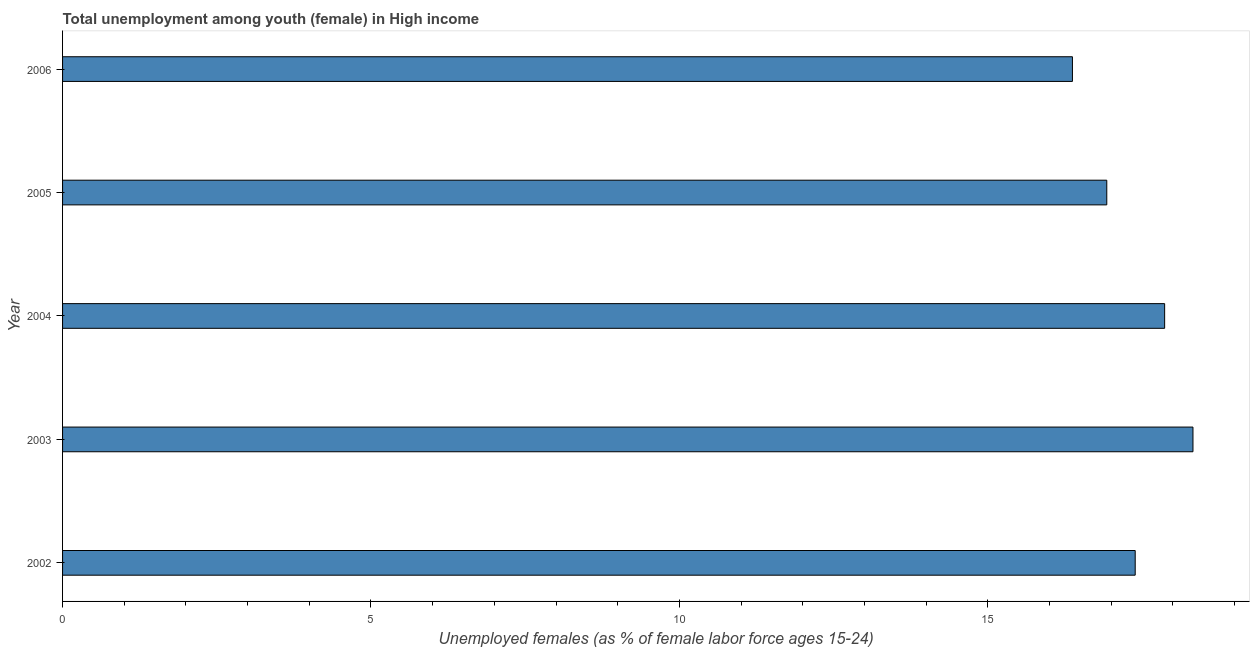Does the graph contain any zero values?
Provide a succinct answer. No. What is the title of the graph?
Provide a short and direct response. Total unemployment among youth (female) in High income. What is the label or title of the X-axis?
Your answer should be compact. Unemployed females (as % of female labor force ages 15-24). What is the label or title of the Y-axis?
Your response must be concise. Year. What is the unemployed female youth population in 2003?
Provide a short and direct response. 18.33. Across all years, what is the maximum unemployed female youth population?
Ensure brevity in your answer.  18.33. Across all years, what is the minimum unemployed female youth population?
Offer a terse response. 16.37. In which year was the unemployed female youth population maximum?
Provide a succinct answer. 2003. In which year was the unemployed female youth population minimum?
Provide a succinct answer. 2006. What is the sum of the unemployed female youth population?
Offer a terse response. 86.89. What is the difference between the unemployed female youth population in 2004 and 2005?
Keep it short and to the point. 0.94. What is the average unemployed female youth population per year?
Keep it short and to the point. 17.38. What is the median unemployed female youth population?
Your answer should be very brief. 17.39. Do a majority of the years between 2003 and 2004 (inclusive) have unemployed female youth population greater than 8 %?
Offer a very short reply. Yes. What is the ratio of the unemployed female youth population in 2002 to that in 2004?
Ensure brevity in your answer.  0.97. Is the difference between the unemployed female youth population in 2003 and 2004 greater than the difference between any two years?
Your answer should be very brief. No. What is the difference between the highest and the second highest unemployed female youth population?
Your answer should be very brief. 0.46. What is the difference between the highest and the lowest unemployed female youth population?
Your response must be concise. 1.95. In how many years, is the unemployed female youth population greater than the average unemployed female youth population taken over all years?
Offer a very short reply. 3. How many years are there in the graph?
Make the answer very short. 5. What is the difference between two consecutive major ticks on the X-axis?
Ensure brevity in your answer.  5. What is the Unemployed females (as % of female labor force ages 15-24) of 2002?
Your answer should be compact. 17.39. What is the Unemployed females (as % of female labor force ages 15-24) in 2003?
Your answer should be compact. 18.33. What is the Unemployed females (as % of female labor force ages 15-24) in 2004?
Your answer should be very brief. 17.87. What is the Unemployed females (as % of female labor force ages 15-24) of 2005?
Provide a short and direct response. 16.93. What is the Unemployed females (as % of female labor force ages 15-24) of 2006?
Make the answer very short. 16.37. What is the difference between the Unemployed females (as % of female labor force ages 15-24) in 2002 and 2003?
Keep it short and to the point. -0.94. What is the difference between the Unemployed females (as % of female labor force ages 15-24) in 2002 and 2004?
Your answer should be very brief. -0.48. What is the difference between the Unemployed females (as % of female labor force ages 15-24) in 2002 and 2005?
Offer a terse response. 0.46. What is the difference between the Unemployed females (as % of female labor force ages 15-24) in 2002 and 2006?
Your response must be concise. 1.02. What is the difference between the Unemployed females (as % of female labor force ages 15-24) in 2003 and 2004?
Offer a very short reply. 0.46. What is the difference between the Unemployed females (as % of female labor force ages 15-24) in 2003 and 2005?
Make the answer very short. 1.4. What is the difference between the Unemployed females (as % of female labor force ages 15-24) in 2003 and 2006?
Offer a very short reply. 1.95. What is the difference between the Unemployed females (as % of female labor force ages 15-24) in 2004 and 2005?
Your response must be concise. 0.94. What is the difference between the Unemployed females (as % of female labor force ages 15-24) in 2004 and 2006?
Your response must be concise. 1.49. What is the difference between the Unemployed females (as % of female labor force ages 15-24) in 2005 and 2006?
Offer a very short reply. 0.56. What is the ratio of the Unemployed females (as % of female labor force ages 15-24) in 2002 to that in 2003?
Your response must be concise. 0.95. What is the ratio of the Unemployed females (as % of female labor force ages 15-24) in 2002 to that in 2004?
Keep it short and to the point. 0.97. What is the ratio of the Unemployed females (as % of female labor force ages 15-24) in 2002 to that in 2006?
Provide a short and direct response. 1.06. What is the ratio of the Unemployed females (as % of female labor force ages 15-24) in 2003 to that in 2004?
Your answer should be very brief. 1.03. What is the ratio of the Unemployed females (as % of female labor force ages 15-24) in 2003 to that in 2005?
Offer a terse response. 1.08. What is the ratio of the Unemployed females (as % of female labor force ages 15-24) in 2003 to that in 2006?
Provide a short and direct response. 1.12. What is the ratio of the Unemployed females (as % of female labor force ages 15-24) in 2004 to that in 2005?
Provide a succinct answer. 1.05. What is the ratio of the Unemployed females (as % of female labor force ages 15-24) in 2004 to that in 2006?
Offer a terse response. 1.09. What is the ratio of the Unemployed females (as % of female labor force ages 15-24) in 2005 to that in 2006?
Ensure brevity in your answer.  1.03. 